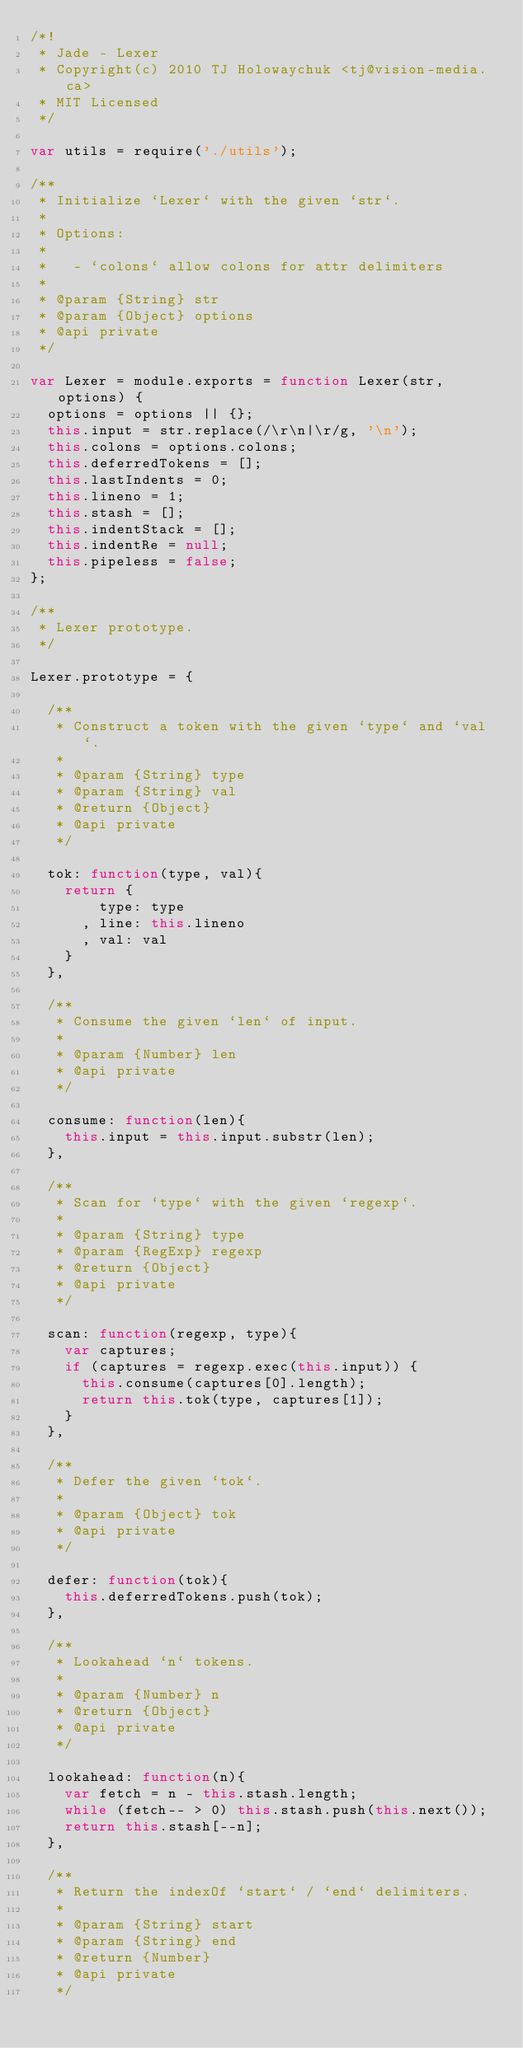<code> <loc_0><loc_0><loc_500><loc_500><_JavaScript_>/*!
 * Jade - Lexer
 * Copyright(c) 2010 TJ Holowaychuk <tj@vision-media.ca>
 * MIT Licensed
 */

var utils = require('./utils');

/**
 * Initialize `Lexer` with the given `str`.
 *
 * Options:
 *
 *   - `colons` allow colons for attr delimiters
 *
 * @param {String} str
 * @param {Object} options
 * @api private
 */

var Lexer = module.exports = function Lexer(str, options) {
  options = options || {};
  this.input = str.replace(/\r\n|\r/g, '\n');
  this.colons = options.colons;
  this.deferredTokens = [];
  this.lastIndents = 0;
  this.lineno = 1;
  this.stash = [];
  this.indentStack = [];
  this.indentRe = null;
  this.pipeless = false;
};

/**
 * Lexer prototype.
 */

Lexer.prototype = {
  
  /**
   * Construct a token with the given `type` and `val`.
   *
   * @param {String} type
   * @param {String} val
   * @return {Object}
   * @api private
   */
  
  tok: function(type, val){
    return {
        type: type
      , line: this.lineno
      , val: val
    }
  },
  
  /**
   * Consume the given `len` of input.
   *
   * @param {Number} len
   * @api private
   */
  
  consume: function(len){
    this.input = this.input.substr(len);
  },
  
  /**
   * Scan for `type` with the given `regexp`.
   *
   * @param {String} type
   * @param {RegExp} regexp
   * @return {Object}
   * @api private
   */
  
  scan: function(regexp, type){
    var captures;
    if (captures = regexp.exec(this.input)) {
      this.consume(captures[0].length);
      return this.tok(type, captures[1]);
    }
  },
  
  /**
   * Defer the given `tok`.
   *
   * @param {Object} tok
   * @api private
   */
  
  defer: function(tok){
    this.deferredTokens.push(tok);
  },
  
  /**
   * Lookahead `n` tokens.
   *
   * @param {Number} n
   * @return {Object}
   * @api private
   */
  
  lookahead: function(n){
    var fetch = n - this.stash.length;
    while (fetch-- > 0) this.stash.push(this.next());
    return this.stash[--n];
  },
  
  /**
   * Return the indexOf `start` / `end` delimiters.
   *
   * @param {String} start
   * @param {String} end
   * @return {Number}
   * @api private
   */</code> 